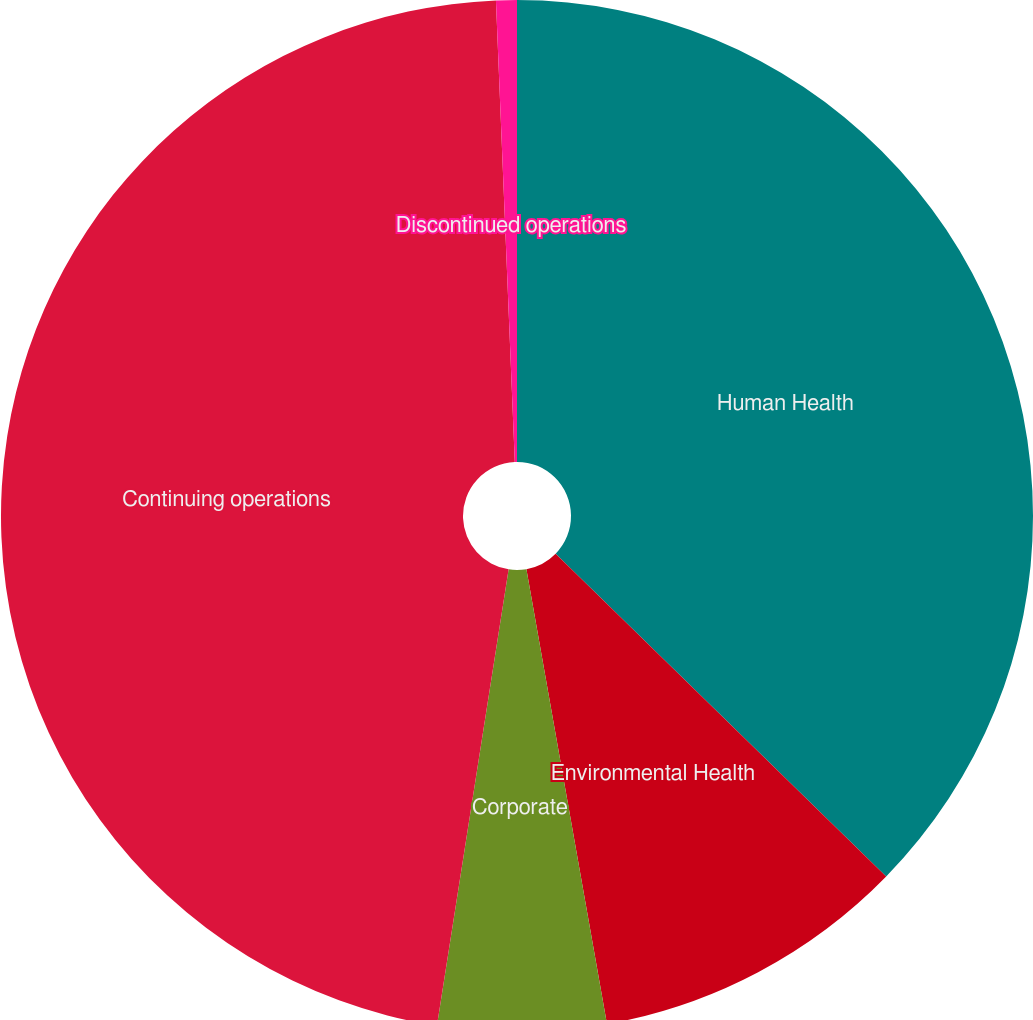<chart> <loc_0><loc_0><loc_500><loc_500><pie_chart><fcel>Human Health<fcel>Environmental Health<fcel>Corporate<fcel>Continuing operations<fcel>Discontinued operations<nl><fcel>37.31%<fcel>9.9%<fcel>5.27%<fcel>46.87%<fcel>0.65%<nl></chart> 